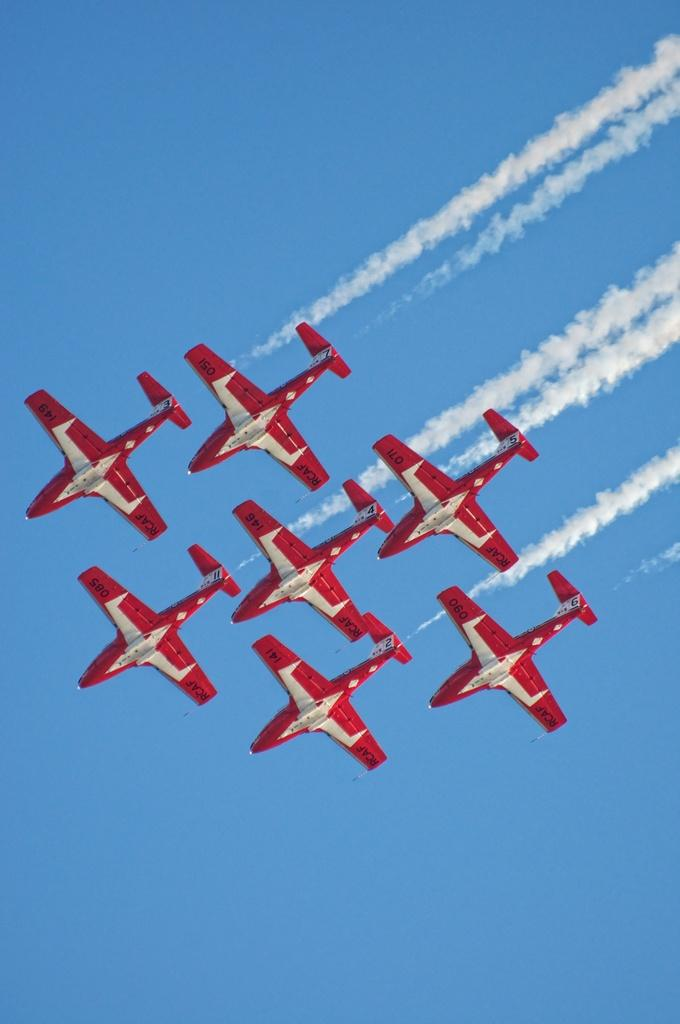How many airplanes are present in the image? There are seven airplanes in the image. What color are the airplanes? The airplanes are red in color. What are the airplanes doing in the image? The airplanes are flying in the sky. What is coming out of the airplanes? The airplanes are emitting smoke. What type of behavior can be observed in the dirt in the image? There is no dirt present in the image, and therefore no behavior can be observed in it. 